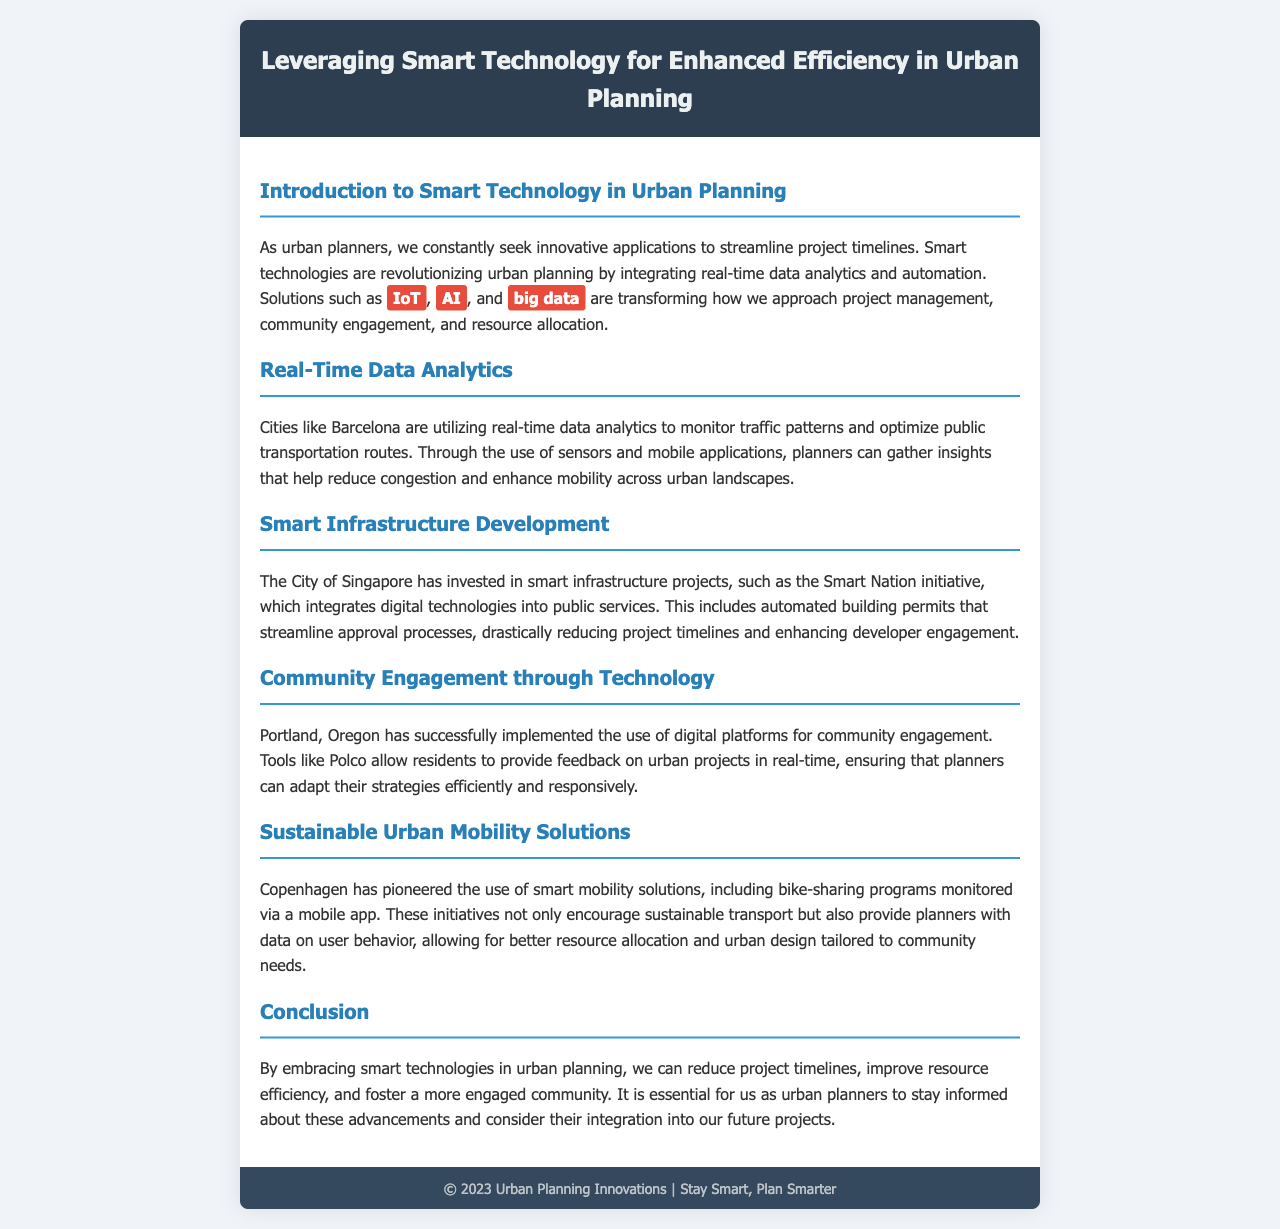What technologies are mentioned as transforming urban planning? The document lists IoT, AI, and big data as technologies transforming urban planning.
Answer: IoT, AI, big data Which city uses real-time data analytics for traffic monitoring? According to the document, Barcelona is utilizing real-time data analytics for this purpose.
Answer: Barcelona What initiative is Singapore known for regarding smart infrastructure? Singapore's Smart Nation initiative incorporates digital technologies into public services.
Answer: Smart Nation Which city has implemented Polco for community engagement? The document states that Portland, Oregon has successfully implemented Polco.
Answer: Portland, Oregon What sustainable transport solution is mentioned in Copenhagen? The document references a bike-sharing program monitored via a mobile app as a sustainable transport solution in Copenhagen.
Answer: bike-sharing program How do smart technologies benefit urban planning according to the conclusion? The conclusion mentions that smart technologies help reduce project timelines and improve resource efficiency.
Answer: reduce project timelines, improve resource efficiency What is the primary focus of this document? The document is primarily focused on leveraging smart technology for enhanced efficiency in urban planning.
Answer: leveraging smart technology for enhanced efficiency What type of tools does Portland use to gather community feedback? The email mentions digital platforms like Polco for gathering feedback in Portland.
Answer: Polco 